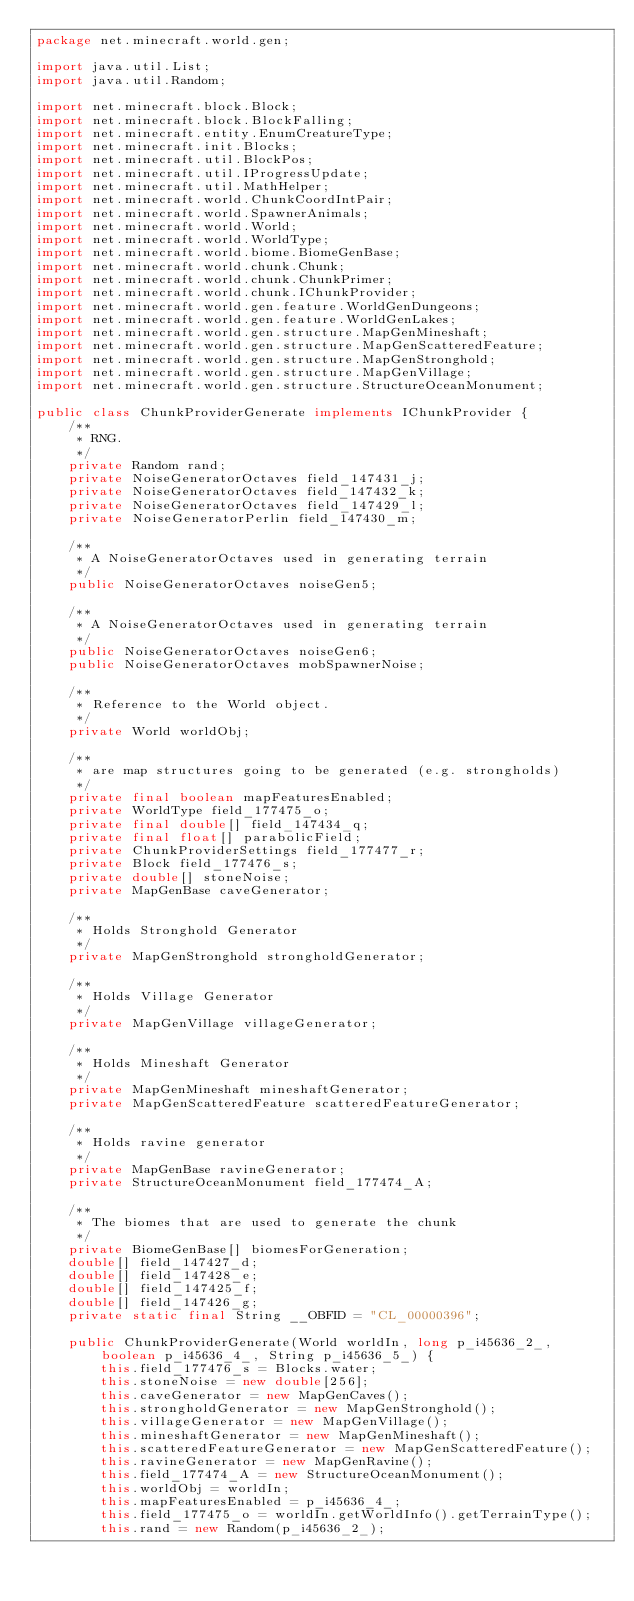Convert code to text. <code><loc_0><loc_0><loc_500><loc_500><_Java_>package net.minecraft.world.gen;

import java.util.List;
import java.util.Random;

import net.minecraft.block.Block;
import net.minecraft.block.BlockFalling;
import net.minecraft.entity.EnumCreatureType;
import net.minecraft.init.Blocks;
import net.minecraft.util.BlockPos;
import net.minecraft.util.IProgressUpdate;
import net.minecraft.util.MathHelper;
import net.minecraft.world.ChunkCoordIntPair;
import net.minecraft.world.SpawnerAnimals;
import net.minecraft.world.World;
import net.minecraft.world.WorldType;
import net.minecraft.world.biome.BiomeGenBase;
import net.minecraft.world.chunk.Chunk;
import net.minecraft.world.chunk.ChunkPrimer;
import net.minecraft.world.chunk.IChunkProvider;
import net.minecraft.world.gen.feature.WorldGenDungeons;
import net.minecraft.world.gen.feature.WorldGenLakes;
import net.minecraft.world.gen.structure.MapGenMineshaft;
import net.minecraft.world.gen.structure.MapGenScatteredFeature;
import net.minecraft.world.gen.structure.MapGenStronghold;
import net.minecraft.world.gen.structure.MapGenVillage;
import net.minecraft.world.gen.structure.StructureOceanMonument;

public class ChunkProviderGenerate implements IChunkProvider {
    /**
     * RNG.
     */
    private Random rand;
    private NoiseGeneratorOctaves field_147431_j;
    private NoiseGeneratorOctaves field_147432_k;
    private NoiseGeneratorOctaves field_147429_l;
    private NoiseGeneratorPerlin field_147430_m;

    /**
     * A NoiseGeneratorOctaves used in generating terrain
     */
    public NoiseGeneratorOctaves noiseGen5;

    /**
     * A NoiseGeneratorOctaves used in generating terrain
     */
    public NoiseGeneratorOctaves noiseGen6;
    public NoiseGeneratorOctaves mobSpawnerNoise;

    /**
     * Reference to the World object.
     */
    private World worldObj;

    /**
     * are map structures going to be generated (e.g. strongholds)
     */
    private final boolean mapFeaturesEnabled;
    private WorldType field_177475_o;
    private final double[] field_147434_q;
    private final float[] parabolicField;
    private ChunkProviderSettings field_177477_r;
    private Block field_177476_s;
    private double[] stoneNoise;
    private MapGenBase caveGenerator;

    /**
     * Holds Stronghold Generator
     */
    private MapGenStronghold strongholdGenerator;

    /**
     * Holds Village Generator
     */
    private MapGenVillage villageGenerator;

    /**
     * Holds Mineshaft Generator
     */
    private MapGenMineshaft mineshaftGenerator;
    private MapGenScatteredFeature scatteredFeatureGenerator;

    /**
     * Holds ravine generator
     */
    private MapGenBase ravineGenerator;
    private StructureOceanMonument field_177474_A;

    /**
     * The biomes that are used to generate the chunk
     */
    private BiomeGenBase[] biomesForGeneration;
    double[] field_147427_d;
    double[] field_147428_e;
    double[] field_147425_f;
    double[] field_147426_g;
    private static final String __OBFID = "CL_00000396";

    public ChunkProviderGenerate(World worldIn, long p_i45636_2_, boolean p_i45636_4_, String p_i45636_5_) {
        this.field_177476_s = Blocks.water;
        this.stoneNoise = new double[256];
        this.caveGenerator = new MapGenCaves();
        this.strongholdGenerator = new MapGenStronghold();
        this.villageGenerator = new MapGenVillage();
        this.mineshaftGenerator = new MapGenMineshaft();
        this.scatteredFeatureGenerator = new MapGenScatteredFeature();
        this.ravineGenerator = new MapGenRavine();
        this.field_177474_A = new StructureOceanMonument();
        this.worldObj = worldIn;
        this.mapFeaturesEnabled = p_i45636_4_;
        this.field_177475_o = worldIn.getWorldInfo().getTerrainType();
        this.rand = new Random(p_i45636_2_);</code> 